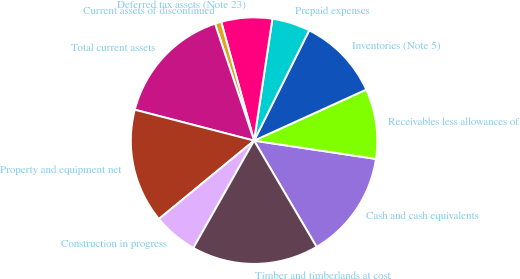<chart> <loc_0><loc_0><loc_500><loc_500><pie_chart><fcel>Cash and cash equivalents<fcel>Receivables less allowances of<fcel>Inventories (Note 5)<fcel>Prepaid expenses<fcel>Deferred tax assets (Note 23)<fcel>Current assets of discontinued<fcel>Total current assets<fcel>Property and equipment net<fcel>Construction in progress<fcel>Timber and timberlands at cost<nl><fcel>14.16%<fcel>9.17%<fcel>10.83%<fcel>5.0%<fcel>6.67%<fcel>0.84%<fcel>15.83%<fcel>15.0%<fcel>5.84%<fcel>16.66%<nl></chart> 